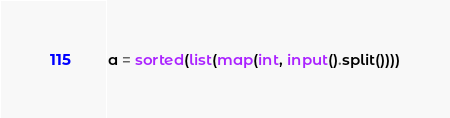<code> <loc_0><loc_0><loc_500><loc_500><_Python_>a = sorted(list(map(int, input().split())))</code> 